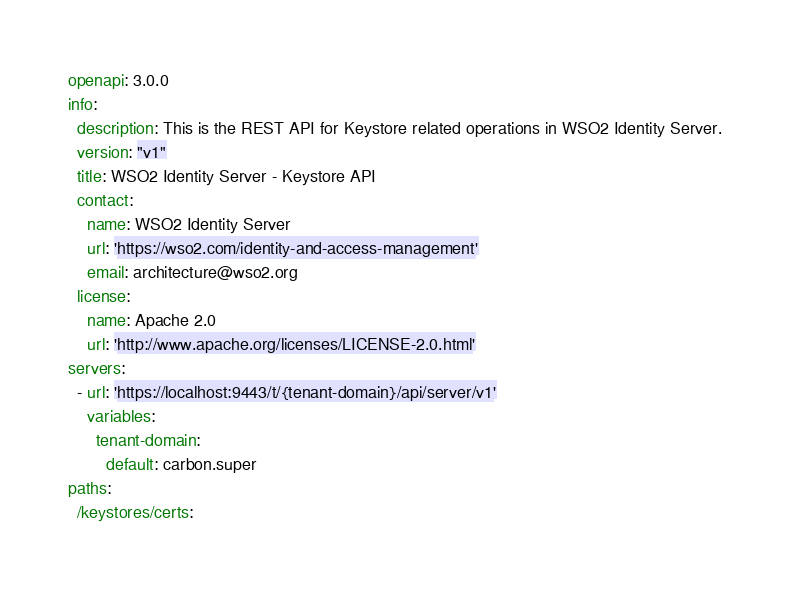<code> <loc_0><loc_0><loc_500><loc_500><_YAML_>openapi: 3.0.0
info:
  description: This is the REST API for Keystore related operations in WSO2 Identity Server.
  version: "v1"
  title: WSO2 Identity Server - Keystore API
  contact:
    name: WSO2 Identity Server
    url: 'https://wso2.com/identity-and-access-management'
    email: architecture@wso2.org
  license:
    name: Apache 2.0
    url: 'http://www.apache.org/licenses/LICENSE-2.0.html'
servers:
  - url: 'https://localhost:9443/t/{tenant-domain}/api/server/v1'
    variables:
      tenant-domain:
        default: carbon.super
paths:
  /keystores/certs:</code> 